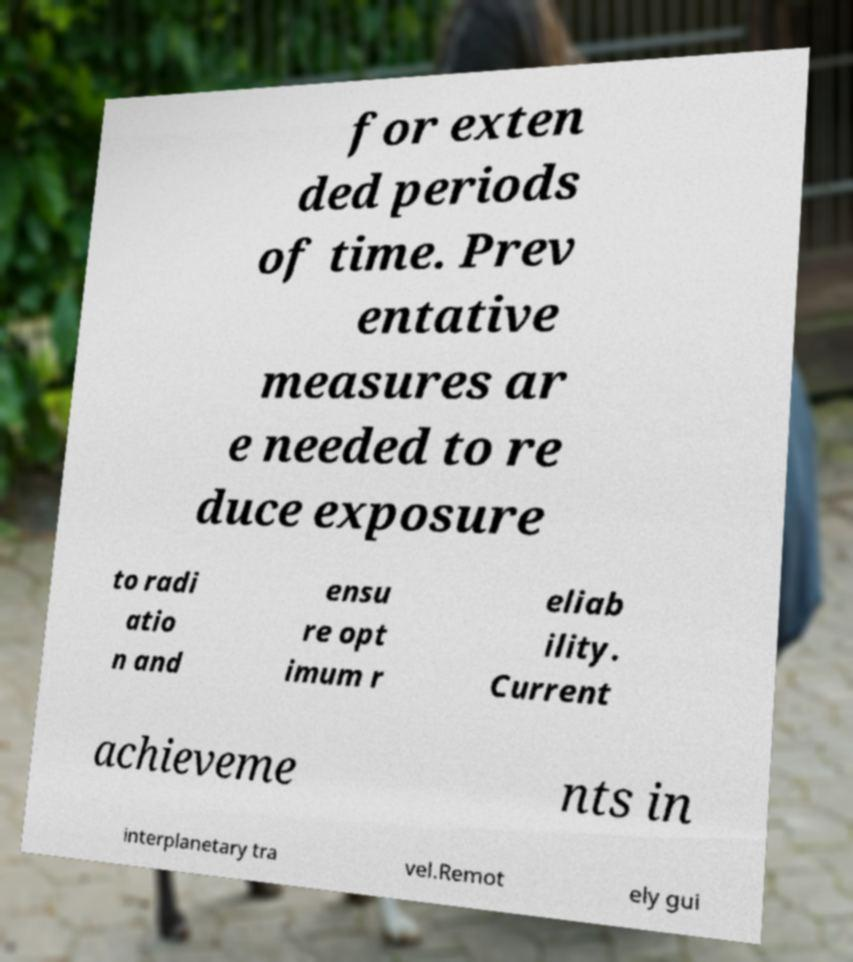Please identify and transcribe the text found in this image. for exten ded periods of time. Prev entative measures ar e needed to re duce exposure to radi atio n and ensu re opt imum r eliab ility. Current achieveme nts in interplanetary tra vel.Remot ely gui 